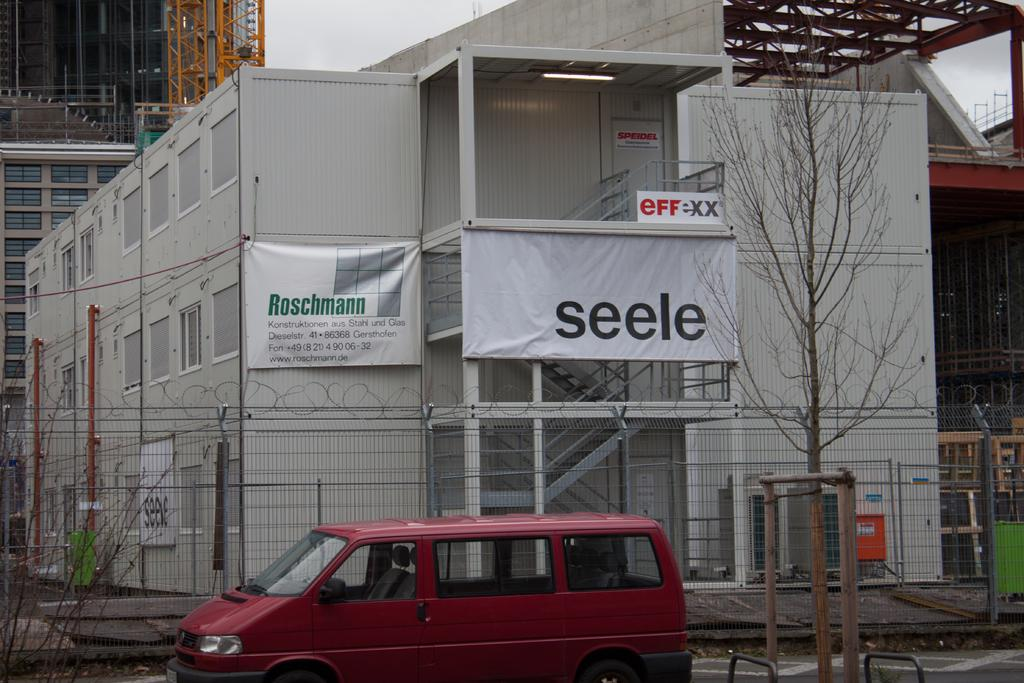What type of structures can be seen in the image? There are buildings in the image. What natural elements are present in the image? There are trees in the image. What type of barrier can be seen in the image? There is a fence in the image. What type of signage is present in the image? There are banners in the image. What type of vehicle is present in the image? There is a van in the image. What is visible at the top of the image? The sky is visible at the top of the image. What type of learning is taking place in the image? There is no indication of learning or any educational activity in the image. What type of operation is being performed on the thing in the image? There is no operation or any activity involving a "thing" in the image. 